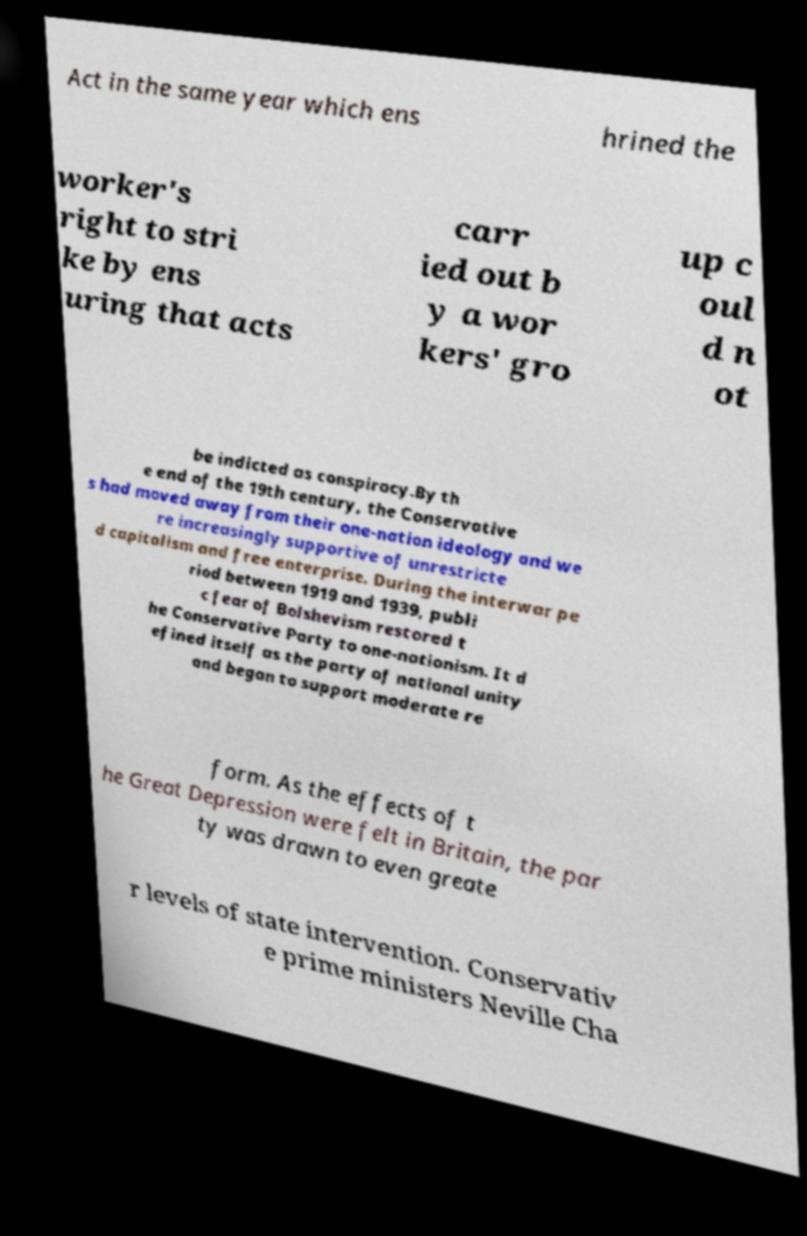For documentation purposes, I need the text within this image transcribed. Could you provide that? Act in the same year which ens hrined the worker's right to stri ke by ens uring that acts carr ied out b y a wor kers' gro up c oul d n ot be indicted as conspiracy.By th e end of the 19th century, the Conservative s had moved away from their one-nation ideology and we re increasingly supportive of unrestricte d capitalism and free enterprise. During the interwar pe riod between 1919 and 1939, publi c fear of Bolshevism restored t he Conservative Party to one-nationism. It d efined itself as the party of national unity and began to support moderate re form. As the effects of t he Great Depression were felt in Britain, the par ty was drawn to even greate r levels of state intervention. Conservativ e prime ministers Neville Cha 